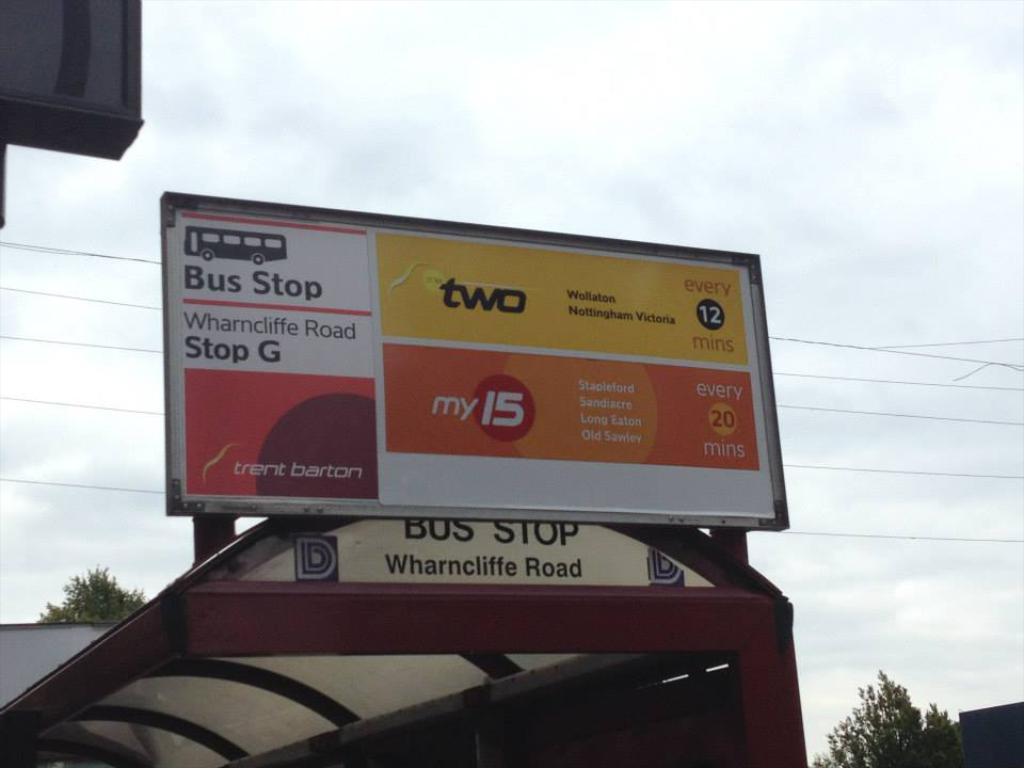<image>
Describe the image concisely. The sign says a bus will stop every 12 minutes. 